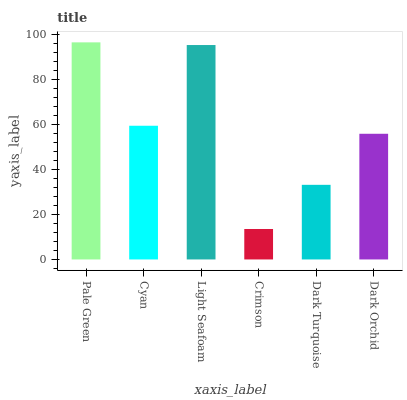Is Crimson the minimum?
Answer yes or no. Yes. Is Pale Green the maximum?
Answer yes or no. Yes. Is Cyan the minimum?
Answer yes or no. No. Is Cyan the maximum?
Answer yes or no. No. Is Pale Green greater than Cyan?
Answer yes or no. Yes. Is Cyan less than Pale Green?
Answer yes or no. Yes. Is Cyan greater than Pale Green?
Answer yes or no. No. Is Pale Green less than Cyan?
Answer yes or no. No. Is Cyan the high median?
Answer yes or no. Yes. Is Dark Orchid the low median?
Answer yes or no. Yes. Is Crimson the high median?
Answer yes or no. No. Is Cyan the low median?
Answer yes or no. No. 